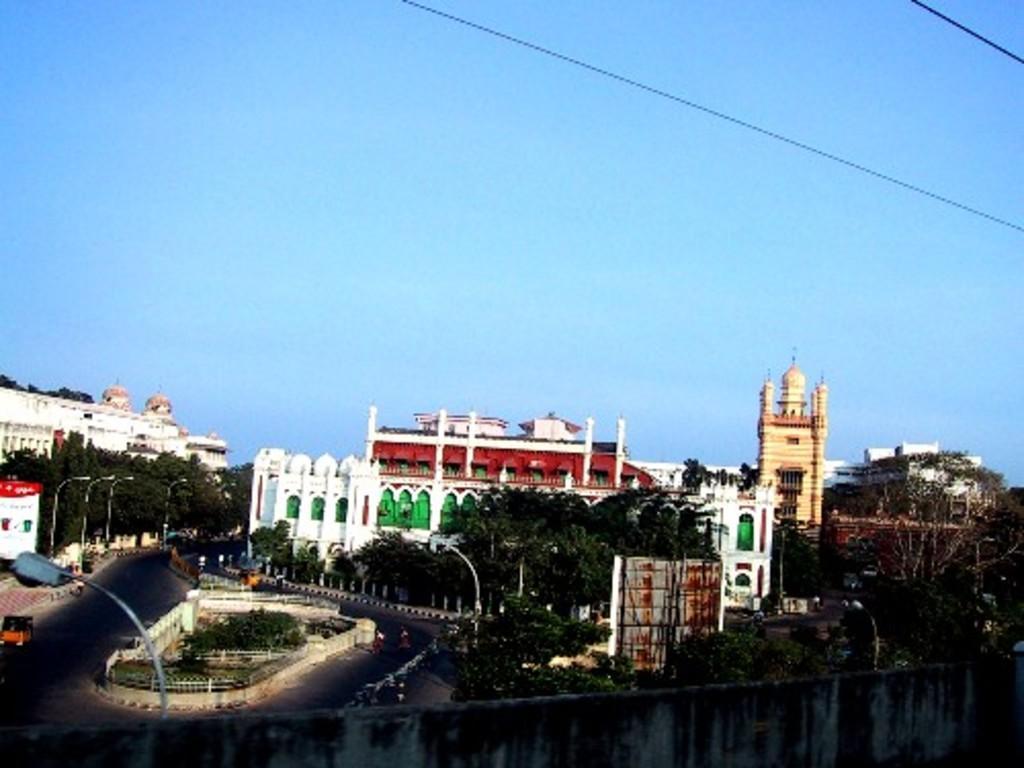Could you give a brief overview of what you see in this image? In the picture we can see a city with roads, trees, houses, buildings, mosques and some historical constructions and we can see some poles with lights to it and in the background we can see a sky. 